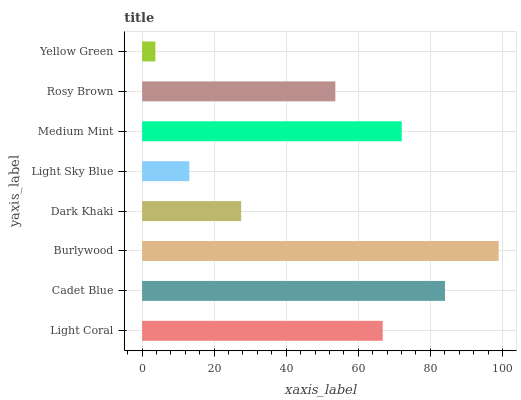Is Yellow Green the minimum?
Answer yes or no. Yes. Is Burlywood the maximum?
Answer yes or no. Yes. Is Cadet Blue the minimum?
Answer yes or no. No. Is Cadet Blue the maximum?
Answer yes or no. No. Is Cadet Blue greater than Light Coral?
Answer yes or no. Yes. Is Light Coral less than Cadet Blue?
Answer yes or no. Yes. Is Light Coral greater than Cadet Blue?
Answer yes or no. No. Is Cadet Blue less than Light Coral?
Answer yes or no. No. Is Light Coral the high median?
Answer yes or no. Yes. Is Rosy Brown the low median?
Answer yes or no. Yes. Is Cadet Blue the high median?
Answer yes or no. No. Is Burlywood the low median?
Answer yes or no. No. 